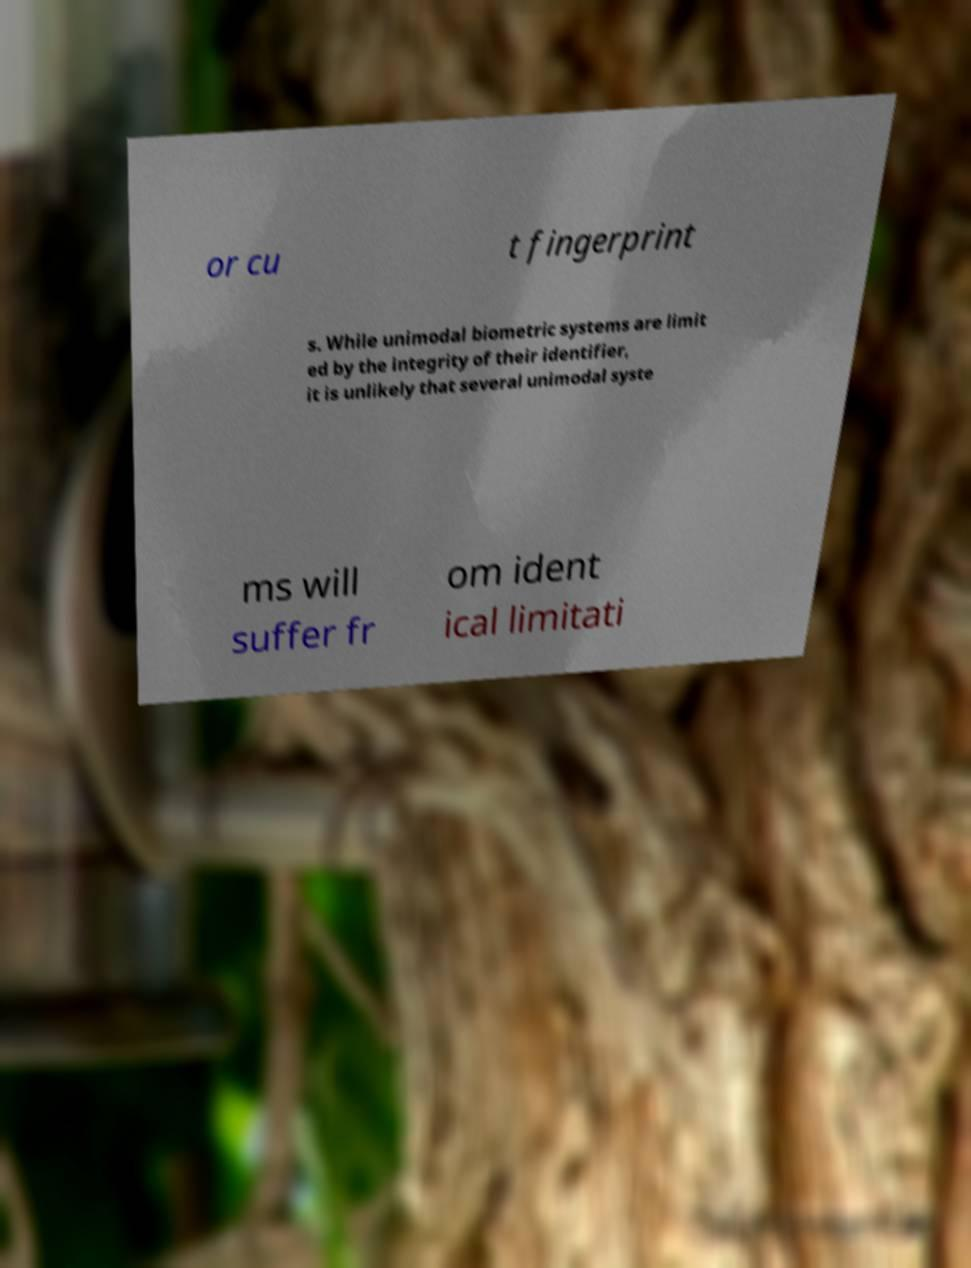Please identify and transcribe the text found in this image. or cu t fingerprint s. While unimodal biometric systems are limit ed by the integrity of their identifier, it is unlikely that several unimodal syste ms will suffer fr om ident ical limitati 